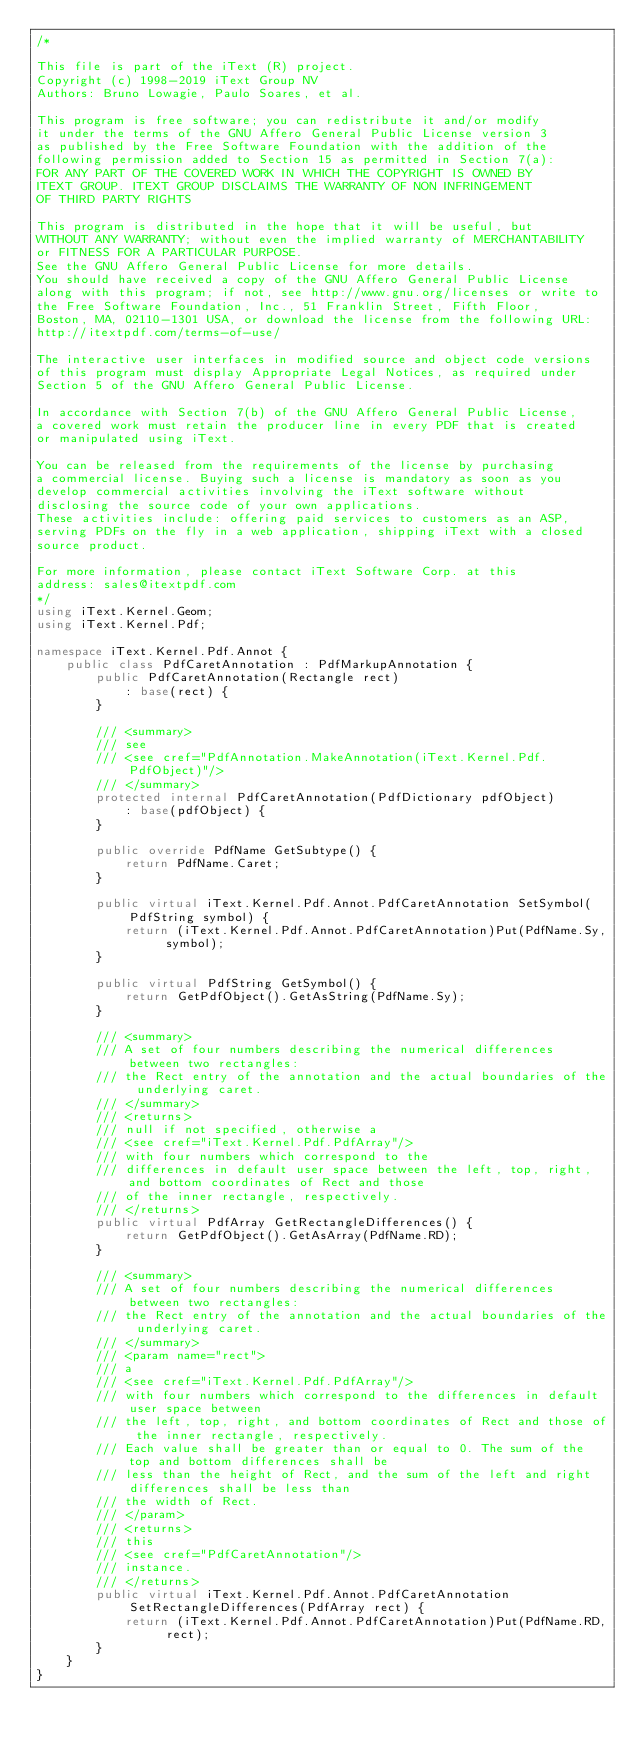Convert code to text. <code><loc_0><loc_0><loc_500><loc_500><_C#_>/*

This file is part of the iText (R) project.
Copyright (c) 1998-2019 iText Group NV
Authors: Bruno Lowagie, Paulo Soares, et al.

This program is free software; you can redistribute it and/or modify
it under the terms of the GNU Affero General Public License version 3
as published by the Free Software Foundation with the addition of the
following permission added to Section 15 as permitted in Section 7(a):
FOR ANY PART OF THE COVERED WORK IN WHICH THE COPYRIGHT IS OWNED BY
ITEXT GROUP. ITEXT GROUP DISCLAIMS THE WARRANTY OF NON INFRINGEMENT
OF THIRD PARTY RIGHTS

This program is distributed in the hope that it will be useful, but
WITHOUT ANY WARRANTY; without even the implied warranty of MERCHANTABILITY
or FITNESS FOR A PARTICULAR PURPOSE.
See the GNU Affero General Public License for more details.
You should have received a copy of the GNU Affero General Public License
along with this program; if not, see http://www.gnu.org/licenses or write to
the Free Software Foundation, Inc., 51 Franklin Street, Fifth Floor,
Boston, MA, 02110-1301 USA, or download the license from the following URL:
http://itextpdf.com/terms-of-use/

The interactive user interfaces in modified source and object code versions
of this program must display Appropriate Legal Notices, as required under
Section 5 of the GNU Affero General Public License.

In accordance with Section 7(b) of the GNU Affero General Public License,
a covered work must retain the producer line in every PDF that is created
or manipulated using iText.

You can be released from the requirements of the license by purchasing
a commercial license. Buying such a license is mandatory as soon as you
develop commercial activities involving the iText software without
disclosing the source code of your own applications.
These activities include: offering paid services to customers as an ASP,
serving PDFs on the fly in a web application, shipping iText with a closed
source product.

For more information, please contact iText Software Corp. at this
address: sales@itextpdf.com
*/
using iText.Kernel.Geom;
using iText.Kernel.Pdf;

namespace iText.Kernel.Pdf.Annot {
    public class PdfCaretAnnotation : PdfMarkupAnnotation {
        public PdfCaretAnnotation(Rectangle rect)
            : base(rect) {
        }

        /// <summary>
        /// see
        /// <see cref="PdfAnnotation.MakeAnnotation(iText.Kernel.Pdf.PdfObject)"/>
        /// </summary>
        protected internal PdfCaretAnnotation(PdfDictionary pdfObject)
            : base(pdfObject) {
        }

        public override PdfName GetSubtype() {
            return PdfName.Caret;
        }

        public virtual iText.Kernel.Pdf.Annot.PdfCaretAnnotation SetSymbol(PdfString symbol) {
            return (iText.Kernel.Pdf.Annot.PdfCaretAnnotation)Put(PdfName.Sy, symbol);
        }

        public virtual PdfString GetSymbol() {
            return GetPdfObject().GetAsString(PdfName.Sy);
        }

        /// <summary>
        /// A set of four numbers describing the numerical differences between two rectangles:
        /// the Rect entry of the annotation and the actual boundaries of the underlying caret.
        /// </summary>
        /// <returns>
        /// null if not specified, otherwise a
        /// <see cref="iText.Kernel.Pdf.PdfArray"/>
        /// with four numbers which correspond to the
        /// differences in default user space between the left, top, right, and bottom coordinates of Rect and those
        /// of the inner rectangle, respectively.
        /// </returns>
        public virtual PdfArray GetRectangleDifferences() {
            return GetPdfObject().GetAsArray(PdfName.RD);
        }

        /// <summary>
        /// A set of four numbers describing the numerical differences between two rectangles:
        /// the Rect entry of the annotation and the actual boundaries of the underlying caret.
        /// </summary>
        /// <param name="rect">
        /// a
        /// <see cref="iText.Kernel.Pdf.PdfArray"/>
        /// with four numbers which correspond to the differences in default user space between
        /// the left, top, right, and bottom coordinates of Rect and those of the inner rectangle, respectively.
        /// Each value shall be greater than or equal to 0. The sum of the top and bottom differences shall be
        /// less than the height of Rect, and the sum of the left and right differences shall be less than
        /// the width of Rect.
        /// </param>
        /// <returns>
        /// this
        /// <see cref="PdfCaretAnnotation"/>
        /// instance.
        /// </returns>
        public virtual iText.Kernel.Pdf.Annot.PdfCaretAnnotation SetRectangleDifferences(PdfArray rect) {
            return (iText.Kernel.Pdf.Annot.PdfCaretAnnotation)Put(PdfName.RD, rect);
        }
    }
}
</code> 